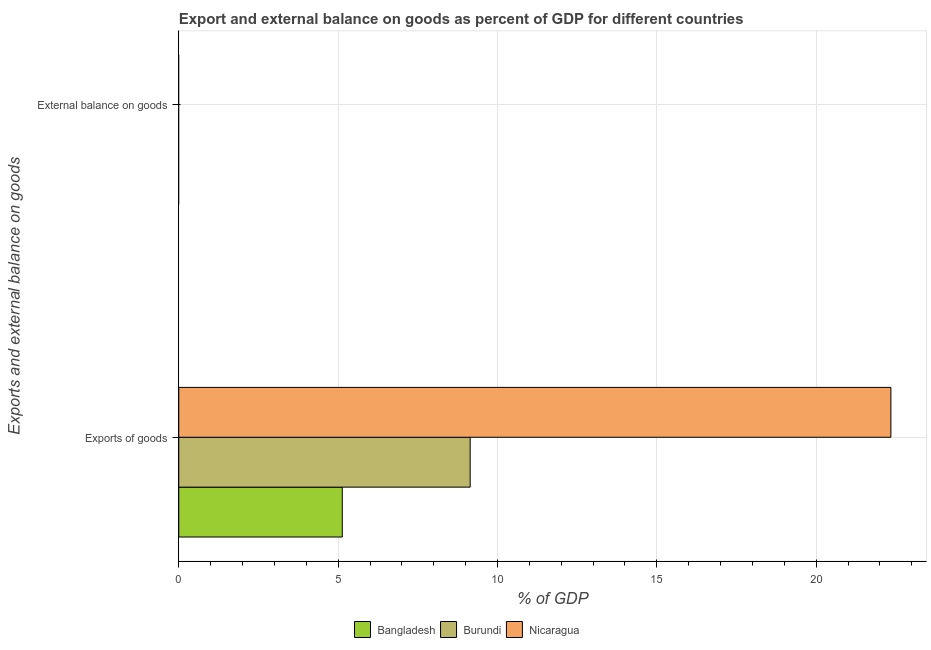Are the number of bars per tick equal to the number of legend labels?
Ensure brevity in your answer.  No. How many bars are there on the 2nd tick from the top?
Provide a short and direct response. 3. How many bars are there on the 2nd tick from the bottom?
Your answer should be compact. 0. What is the label of the 2nd group of bars from the top?
Give a very brief answer. Exports of goods. What is the external balance on goods as percentage of gdp in Nicaragua?
Keep it short and to the point. 0. Across all countries, what is the maximum export of goods as percentage of gdp?
Provide a succinct answer. 22.34. Across all countries, what is the minimum export of goods as percentage of gdp?
Your answer should be very brief. 5.13. In which country was the export of goods as percentage of gdp maximum?
Your answer should be very brief. Nicaragua. What is the total export of goods as percentage of gdp in the graph?
Ensure brevity in your answer.  36.62. What is the difference between the export of goods as percentage of gdp in Nicaragua and that in Bangladesh?
Offer a very short reply. 17.21. What is the difference between the export of goods as percentage of gdp in Burundi and the external balance on goods as percentage of gdp in Nicaragua?
Your answer should be compact. 9.14. What is the average export of goods as percentage of gdp per country?
Your answer should be compact. 12.21. What is the ratio of the export of goods as percentage of gdp in Nicaragua to that in Bangladesh?
Ensure brevity in your answer.  4.35. Is the export of goods as percentage of gdp in Nicaragua less than that in Burundi?
Your answer should be compact. No. In how many countries, is the export of goods as percentage of gdp greater than the average export of goods as percentage of gdp taken over all countries?
Your response must be concise. 1. How many bars are there?
Keep it short and to the point. 3. Are all the bars in the graph horizontal?
Keep it short and to the point. Yes. Are the values on the major ticks of X-axis written in scientific E-notation?
Offer a very short reply. No. Does the graph contain grids?
Give a very brief answer. Yes. Where does the legend appear in the graph?
Offer a terse response. Bottom center. How many legend labels are there?
Your response must be concise. 3. How are the legend labels stacked?
Your answer should be very brief. Horizontal. What is the title of the graph?
Make the answer very short. Export and external balance on goods as percent of GDP for different countries. Does "Middle East & North Africa (developing only)" appear as one of the legend labels in the graph?
Your answer should be very brief. No. What is the label or title of the X-axis?
Your answer should be very brief. % of GDP. What is the label or title of the Y-axis?
Your answer should be compact. Exports and external balance on goods. What is the % of GDP of Bangladesh in Exports of goods?
Your response must be concise. 5.13. What is the % of GDP in Burundi in Exports of goods?
Your answer should be very brief. 9.14. What is the % of GDP of Nicaragua in Exports of goods?
Provide a succinct answer. 22.34. What is the % of GDP in Bangladesh in External balance on goods?
Your answer should be very brief. 0. What is the % of GDP of Burundi in External balance on goods?
Give a very brief answer. 0. Across all Exports and external balance on goods, what is the maximum % of GDP in Bangladesh?
Provide a short and direct response. 5.13. Across all Exports and external balance on goods, what is the maximum % of GDP of Burundi?
Provide a succinct answer. 9.14. Across all Exports and external balance on goods, what is the maximum % of GDP of Nicaragua?
Your answer should be very brief. 22.34. Across all Exports and external balance on goods, what is the minimum % of GDP of Bangladesh?
Offer a very short reply. 0. Across all Exports and external balance on goods, what is the minimum % of GDP of Nicaragua?
Your answer should be very brief. 0. What is the total % of GDP in Bangladesh in the graph?
Provide a succinct answer. 5.13. What is the total % of GDP of Burundi in the graph?
Your response must be concise. 9.14. What is the total % of GDP of Nicaragua in the graph?
Provide a succinct answer. 22.34. What is the average % of GDP of Bangladesh per Exports and external balance on goods?
Offer a terse response. 2.57. What is the average % of GDP of Burundi per Exports and external balance on goods?
Offer a terse response. 4.57. What is the average % of GDP in Nicaragua per Exports and external balance on goods?
Give a very brief answer. 11.17. What is the difference between the % of GDP in Bangladesh and % of GDP in Burundi in Exports of goods?
Offer a very short reply. -4.01. What is the difference between the % of GDP in Bangladesh and % of GDP in Nicaragua in Exports of goods?
Keep it short and to the point. -17.21. What is the difference between the % of GDP in Burundi and % of GDP in Nicaragua in Exports of goods?
Your answer should be compact. -13.2. What is the difference between the highest and the lowest % of GDP in Bangladesh?
Provide a succinct answer. 5.13. What is the difference between the highest and the lowest % of GDP in Burundi?
Your response must be concise. 9.14. What is the difference between the highest and the lowest % of GDP of Nicaragua?
Offer a very short reply. 22.34. 